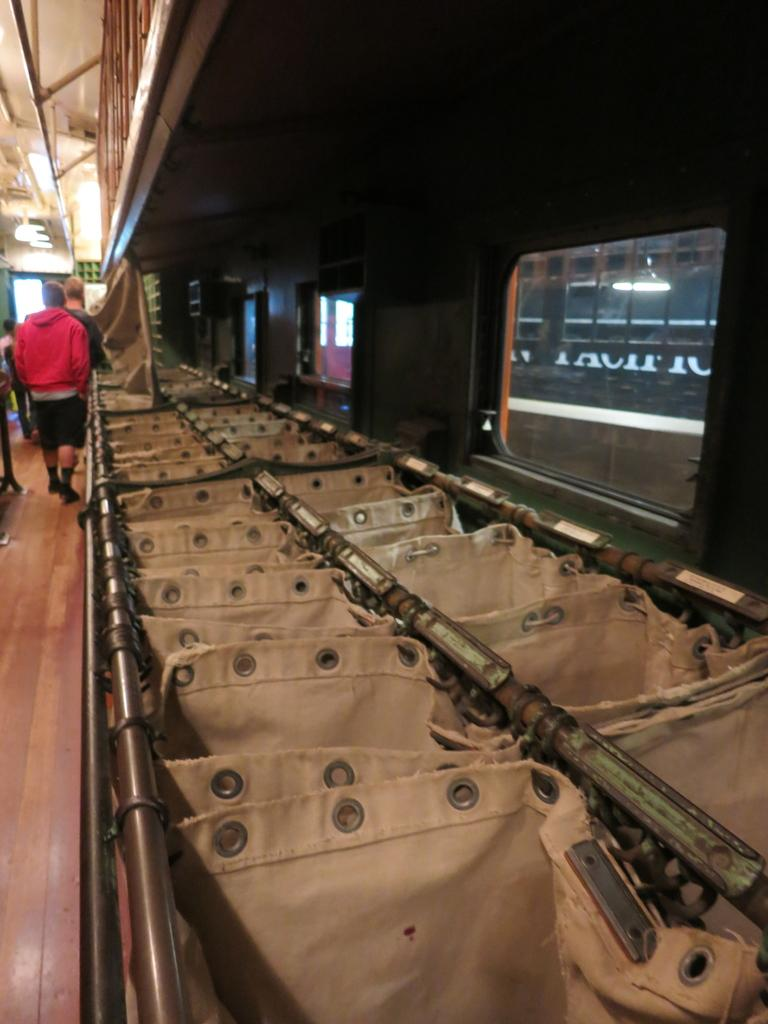What is happening on the left side of the image? There is a man walking on the left side of the image. What is the man wearing? The man is wearing a red coat. What can be seen at the top of the image? There are lights visible at the top of the image. What is on the right side of the image? There is a glass window on the right side of the image. What type of competition is the man participating in, as seen in the image? There is no competition visible in the image; it simply shows a man walking while wearing a red coat. Can you describe the patch on the man's coat in the image? There is no patch visible on the man's coat in the image. 